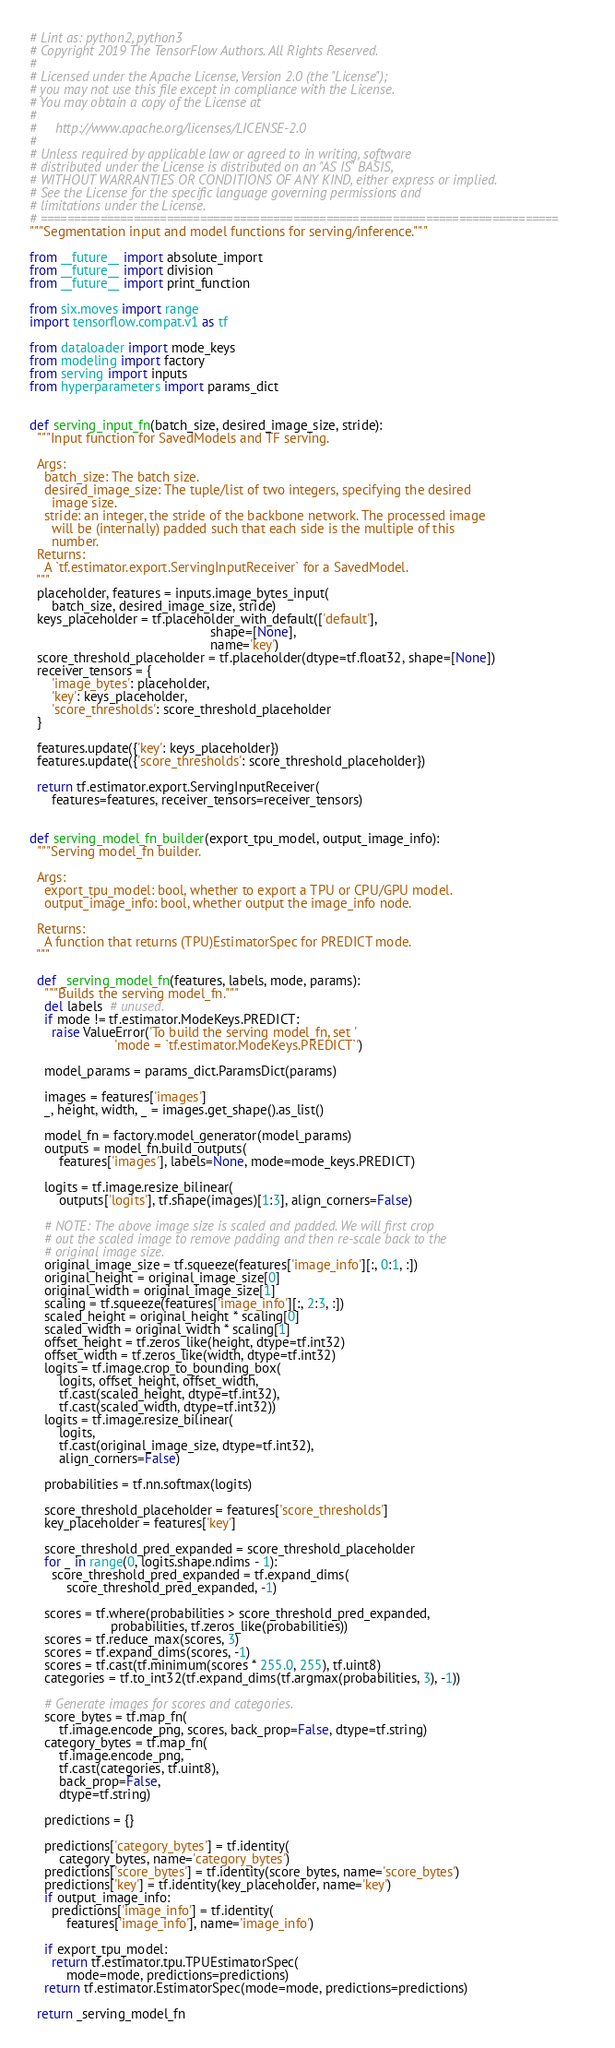<code> <loc_0><loc_0><loc_500><loc_500><_Python_># Lint as: python2, python3
# Copyright 2019 The TensorFlow Authors. All Rights Reserved.
#
# Licensed under the Apache License, Version 2.0 (the "License");
# you may not use this file except in compliance with the License.
# You may obtain a copy of the License at
#
#     http://www.apache.org/licenses/LICENSE-2.0
#
# Unless required by applicable law or agreed to in writing, software
# distributed under the License is distributed on an "AS IS" BASIS,
# WITHOUT WARRANTIES OR CONDITIONS OF ANY KIND, either express or implied.
# See the License for the specific language governing permissions and
# limitations under the License.
# ==============================================================================
"""Segmentation input and model functions for serving/inference."""

from __future__ import absolute_import
from __future__ import division
from __future__ import print_function

from six.moves import range
import tensorflow.compat.v1 as tf

from dataloader import mode_keys
from modeling import factory
from serving import inputs
from hyperparameters import params_dict


def serving_input_fn(batch_size, desired_image_size, stride):
  """Input function for SavedModels and TF serving.

  Args:
    batch_size: The batch size.
    desired_image_size: The tuple/list of two integers, specifying the desired
      image size.
    stride: an integer, the stride of the backbone network. The processed image
      will be (internally) padded such that each side is the multiple of this
      number.
  Returns:
    A `tf.estimator.export.ServingInputReceiver` for a SavedModel.
  """
  placeholder, features = inputs.image_bytes_input(
      batch_size, desired_image_size, stride)
  keys_placeholder = tf.placeholder_with_default(['default'],
                                                 shape=[None],
                                                 name='key')
  score_threshold_placeholder = tf.placeholder(dtype=tf.float32, shape=[None])
  receiver_tensors = {
      'image_bytes': placeholder,
      'key': keys_placeholder,
      'score_thresholds': score_threshold_placeholder
  }

  features.update({'key': keys_placeholder})
  features.update({'score_thresholds': score_threshold_placeholder})

  return tf.estimator.export.ServingInputReceiver(
      features=features, receiver_tensors=receiver_tensors)


def serving_model_fn_builder(export_tpu_model, output_image_info):
  """Serving model_fn builder.

  Args:
    export_tpu_model: bool, whether to export a TPU or CPU/GPU model.
    output_image_info: bool, whether output the image_info node.

  Returns:
    A function that returns (TPU)EstimatorSpec for PREDICT mode.
  """

  def _serving_model_fn(features, labels, mode, params):
    """Builds the serving model_fn."""
    del labels  # unused.
    if mode != tf.estimator.ModeKeys.PREDICT:
      raise ValueError('To build the serving model_fn, set '
                       'mode = `tf.estimator.ModeKeys.PREDICT`')

    model_params = params_dict.ParamsDict(params)

    images = features['images']
    _, height, width, _ = images.get_shape().as_list()

    model_fn = factory.model_generator(model_params)
    outputs = model_fn.build_outputs(
        features['images'], labels=None, mode=mode_keys.PREDICT)

    logits = tf.image.resize_bilinear(
        outputs['logits'], tf.shape(images)[1:3], align_corners=False)

    # NOTE: The above image size is scaled and padded. We will first crop
    # out the scaled image to remove padding and then re-scale back to the
    # original image size.
    original_image_size = tf.squeeze(features['image_info'][:, 0:1, :])
    original_height = original_image_size[0]
    original_width = original_image_size[1]
    scaling = tf.squeeze(features['image_info'][:, 2:3, :])
    scaled_height = original_height * scaling[0]
    scaled_width = original_width * scaling[1]
    offset_height = tf.zeros_like(height, dtype=tf.int32)
    offset_width = tf.zeros_like(width, dtype=tf.int32)
    logits = tf.image.crop_to_bounding_box(
        logits, offset_height, offset_width,
        tf.cast(scaled_height, dtype=tf.int32),
        tf.cast(scaled_width, dtype=tf.int32))
    logits = tf.image.resize_bilinear(
        logits,
        tf.cast(original_image_size, dtype=tf.int32),
        align_corners=False)

    probabilities = tf.nn.softmax(logits)

    score_threshold_placeholder = features['score_thresholds']
    key_placeholder = features['key']

    score_threshold_pred_expanded = score_threshold_placeholder
    for _ in range(0, logits.shape.ndims - 1):
      score_threshold_pred_expanded = tf.expand_dims(
          score_threshold_pred_expanded, -1)

    scores = tf.where(probabilities > score_threshold_pred_expanded,
                      probabilities, tf.zeros_like(probabilities))
    scores = tf.reduce_max(scores, 3)
    scores = tf.expand_dims(scores, -1)
    scores = tf.cast(tf.minimum(scores * 255.0, 255), tf.uint8)
    categories = tf.to_int32(tf.expand_dims(tf.argmax(probabilities, 3), -1))

    # Generate images for scores and categories.
    score_bytes = tf.map_fn(
        tf.image.encode_png, scores, back_prop=False, dtype=tf.string)
    category_bytes = tf.map_fn(
        tf.image.encode_png,
        tf.cast(categories, tf.uint8),
        back_prop=False,
        dtype=tf.string)

    predictions = {}

    predictions['category_bytes'] = tf.identity(
        category_bytes, name='category_bytes')
    predictions['score_bytes'] = tf.identity(score_bytes, name='score_bytes')
    predictions['key'] = tf.identity(key_placeholder, name='key')
    if output_image_info:
      predictions['image_info'] = tf.identity(
          features['image_info'], name='image_info')

    if export_tpu_model:
      return tf.estimator.tpu.TPUEstimatorSpec(
          mode=mode, predictions=predictions)
    return tf.estimator.EstimatorSpec(mode=mode, predictions=predictions)

  return _serving_model_fn
</code> 